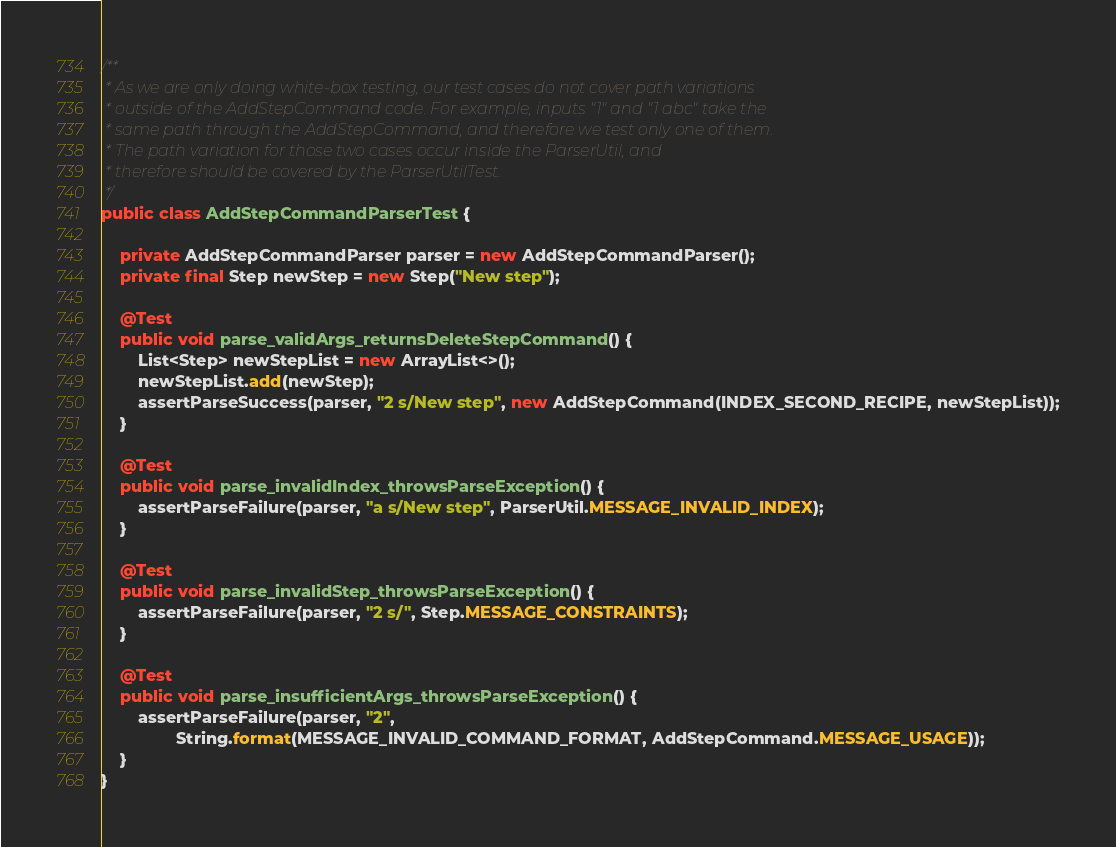Convert code to text. <code><loc_0><loc_0><loc_500><loc_500><_Java_>
/**
 * As we are only doing white-box testing, our test cases do not cover path variations
 * outside of the AddStepCommand code. For example, inputs "1" and "1 abc" take the
 * same path through the AddStepCommand, and therefore we test only one of them.
 * The path variation for those two cases occur inside the ParserUtil, and
 * therefore should be covered by the ParserUtilTest.
 */
public class AddStepCommandParserTest {

    private AddStepCommandParser parser = new AddStepCommandParser();
    private final Step newStep = new Step("New step");

    @Test
    public void parse_validArgs_returnsDeleteStepCommand() {
        List<Step> newStepList = new ArrayList<>();
        newStepList.add(newStep);
        assertParseSuccess(parser, "2 s/New step", new AddStepCommand(INDEX_SECOND_RECIPE, newStepList));
    }

    @Test
    public void parse_invalidIndex_throwsParseException() {
        assertParseFailure(parser, "a s/New step", ParserUtil.MESSAGE_INVALID_INDEX);
    }

    @Test
    public void parse_invalidStep_throwsParseException() {
        assertParseFailure(parser, "2 s/", Step.MESSAGE_CONSTRAINTS);
    }

    @Test
    public void parse_insufficientArgs_throwsParseException() {
        assertParseFailure(parser, "2",
                String.format(MESSAGE_INVALID_COMMAND_FORMAT, AddStepCommand.MESSAGE_USAGE));
    }
}
</code> 